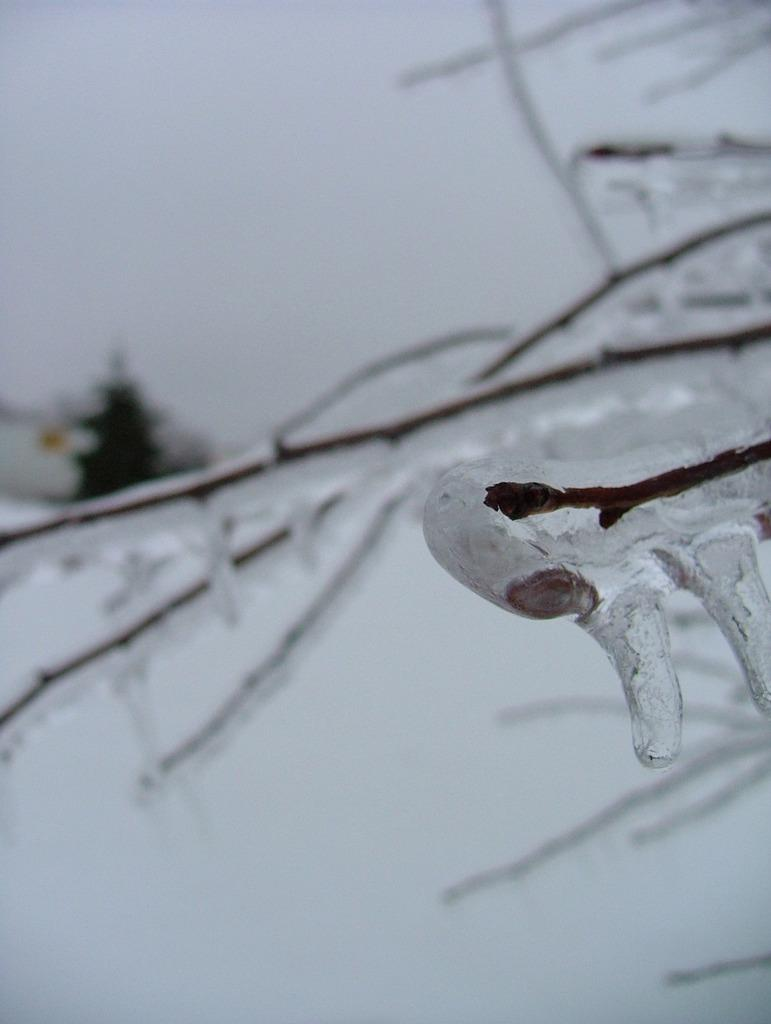What type of vegetation is present in the image? There are dry tree branches in the image. What is covering the tree branches? The tree branches are covered in snow. Can you describe the background of the image? The background of the image is blurred. How many seeds can be seen on the tree branches in the image? There are no seeds visible on the tree branches in the image. What level of difficulty is the image rated on a scale of 1 to 10? The image does not have a difficulty rating, as it is not a game or challenge. 